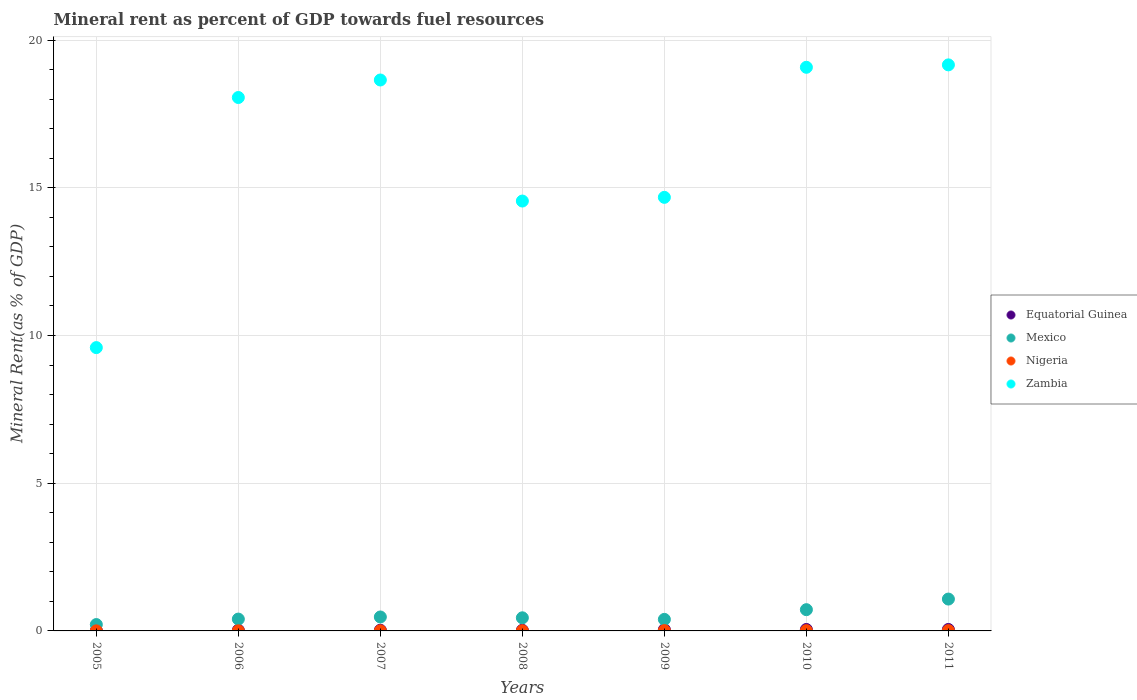How many different coloured dotlines are there?
Your answer should be very brief. 4. Is the number of dotlines equal to the number of legend labels?
Ensure brevity in your answer.  Yes. What is the mineral rent in Nigeria in 2007?
Keep it short and to the point. 0. Across all years, what is the maximum mineral rent in Nigeria?
Give a very brief answer. 0.01. Across all years, what is the minimum mineral rent in Nigeria?
Provide a short and direct response. 0. What is the total mineral rent in Nigeria in the graph?
Ensure brevity in your answer.  0.05. What is the difference between the mineral rent in Equatorial Guinea in 2006 and that in 2008?
Your answer should be very brief. 0. What is the difference between the mineral rent in Zambia in 2011 and the mineral rent in Equatorial Guinea in 2009?
Provide a succinct answer. 19.12. What is the average mineral rent in Equatorial Guinea per year?
Ensure brevity in your answer.  0.03. In the year 2008, what is the difference between the mineral rent in Nigeria and mineral rent in Mexico?
Keep it short and to the point. -0.44. What is the ratio of the mineral rent in Equatorial Guinea in 2006 to that in 2010?
Your answer should be very brief. 0.48. Is the mineral rent in Equatorial Guinea in 2005 less than that in 2007?
Your answer should be very brief. Yes. What is the difference between the highest and the second highest mineral rent in Zambia?
Your answer should be compact. 0.08. What is the difference between the highest and the lowest mineral rent in Equatorial Guinea?
Give a very brief answer. 0.04. Is the sum of the mineral rent in Equatorial Guinea in 2009 and 2011 greater than the maximum mineral rent in Mexico across all years?
Your answer should be very brief. No. Is it the case that in every year, the sum of the mineral rent in Mexico and mineral rent in Equatorial Guinea  is greater than the sum of mineral rent in Zambia and mineral rent in Nigeria?
Provide a short and direct response. No. Does the mineral rent in Nigeria monotonically increase over the years?
Make the answer very short. No. How many dotlines are there?
Make the answer very short. 4. How many years are there in the graph?
Give a very brief answer. 7. What is the difference between two consecutive major ticks on the Y-axis?
Offer a terse response. 5. Are the values on the major ticks of Y-axis written in scientific E-notation?
Your answer should be compact. No. Does the graph contain any zero values?
Your answer should be very brief. No. Does the graph contain grids?
Your response must be concise. Yes. How many legend labels are there?
Offer a terse response. 4. What is the title of the graph?
Your answer should be very brief. Mineral rent as percent of GDP towards fuel resources. Does "Hungary" appear as one of the legend labels in the graph?
Your answer should be very brief. No. What is the label or title of the Y-axis?
Offer a very short reply. Mineral Rent(as % of GDP). What is the Mineral Rent(as % of GDP) of Equatorial Guinea in 2005?
Keep it short and to the point. 0.01. What is the Mineral Rent(as % of GDP) of Mexico in 2005?
Provide a succinct answer. 0.22. What is the Mineral Rent(as % of GDP) of Nigeria in 2005?
Provide a short and direct response. 0. What is the Mineral Rent(as % of GDP) in Zambia in 2005?
Your answer should be compact. 9.59. What is the Mineral Rent(as % of GDP) of Equatorial Guinea in 2006?
Your response must be concise. 0.02. What is the Mineral Rent(as % of GDP) in Mexico in 2006?
Provide a short and direct response. 0.4. What is the Mineral Rent(as % of GDP) of Nigeria in 2006?
Keep it short and to the point. 0. What is the Mineral Rent(as % of GDP) in Zambia in 2006?
Give a very brief answer. 18.06. What is the Mineral Rent(as % of GDP) of Equatorial Guinea in 2007?
Your response must be concise. 0.02. What is the Mineral Rent(as % of GDP) of Mexico in 2007?
Offer a terse response. 0.47. What is the Mineral Rent(as % of GDP) of Nigeria in 2007?
Ensure brevity in your answer.  0. What is the Mineral Rent(as % of GDP) in Zambia in 2007?
Your answer should be very brief. 18.65. What is the Mineral Rent(as % of GDP) of Equatorial Guinea in 2008?
Keep it short and to the point. 0.02. What is the Mineral Rent(as % of GDP) of Mexico in 2008?
Keep it short and to the point. 0.44. What is the Mineral Rent(as % of GDP) in Nigeria in 2008?
Your answer should be very brief. 0.01. What is the Mineral Rent(as % of GDP) of Zambia in 2008?
Your answer should be very brief. 14.55. What is the Mineral Rent(as % of GDP) of Equatorial Guinea in 2009?
Make the answer very short. 0.04. What is the Mineral Rent(as % of GDP) in Mexico in 2009?
Your answer should be compact. 0.39. What is the Mineral Rent(as % of GDP) of Nigeria in 2009?
Provide a short and direct response. 0.01. What is the Mineral Rent(as % of GDP) in Zambia in 2009?
Your answer should be very brief. 14.68. What is the Mineral Rent(as % of GDP) of Equatorial Guinea in 2010?
Give a very brief answer. 0.05. What is the Mineral Rent(as % of GDP) of Mexico in 2010?
Keep it short and to the point. 0.72. What is the Mineral Rent(as % of GDP) in Nigeria in 2010?
Ensure brevity in your answer.  0.01. What is the Mineral Rent(as % of GDP) of Zambia in 2010?
Make the answer very short. 19.08. What is the Mineral Rent(as % of GDP) in Equatorial Guinea in 2011?
Make the answer very short. 0.05. What is the Mineral Rent(as % of GDP) in Mexico in 2011?
Provide a short and direct response. 1.08. What is the Mineral Rent(as % of GDP) in Nigeria in 2011?
Provide a succinct answer. 0.01. What is the Mineral Rent(as % of GDP) of Zambia in 2011?
Keep it short and to the point. 19.16. Across all years, what is the maximum Mineral Rent(as % of GDP) in Equatorial Guinea?
Provide a short and direct response. 0.05. Across all years, what is the maximum Mineral Rent(as % of GDP) in Mexico?
Ensure brevity in your answer.  1.08. Across all years, what is the maximum Mineral Rent(as % of GDP) of Nigeria?
Offer a terse response. 0.01. Across all years, what is the maximum Mineral Rent(as % of GDP) of Zambia?
Give a very brief answer. 19.16. Across all years, what is the minimum Mineral Rent(as % of GDP) in Equatorial Guinea?
Keep it short and to the point. 0.01. Across all years, what is the minimum Mineral Rent(as % of GDP) of Mexico?
Your response must be concise. 0.22. Across all years, what is the minimum Mineral Rent(as % of GDP) of Nigeria?
Your answer should be very brief. 0. Across all years, what is the minimum Mineral Rent(as % of GDP) in Zambia?
Provide a short and direct response. 9.59. What is the total Mineral Rent(as % of GDP) of Equatorial Guinea in the graph?
Provide a short and direct response. 0.22. What is the total Mineral Rent(as % of GDP) in Mexico in the graph?
Offer a terse response. 3.72. What is the total Mineral Rent(as % of GDP) in Nigeria in the graph?
Provide a succinct answer. 0.05. What is the total Mineral Rent(as % of GDP) in Zambia in the graph?
Provide a short and direct response. 113.78. What is the difference between the Mineral Rent(as % of GDP) in Equatorial Guinea in 2005 and that in 2006?
Provide a succinct answer. -0.01. What is the difference between the Mineral Rent(as % of GDP) of Mexico in 2005 and that in 2006?
Your response must be concise. -0.19. What is the difference between the Mineral Rent(as % of GDP) in Nigeria in 2005 and that in 2006?
Offer a terse response. -0. What is the difference between the Mineral Rent(as % of GDP) of Zambia in 2005 and that in 2006?
Offer a terse response. -8.47. What is the difference between the Mineral Rent(as % of GDP) in Equatorial Guinea in 2005 and that in 2007?
Provide a succinct answer. -0.01. What is the difference between the Mineral Rent(as % of GDP) of Mexico in 2005 and that in 2007?
Keep it short and to the point. -0.26. What is the difference between the Mineral Rent(as % of GDP) in Nigeria in 2005 and that in 2007?
Give a very brief answer. -0. What is the difference between the Mineral Rent(as % of GDP) of Zambia in 2005 and that in 2007?
Provide a succinct answer. -9.06. What is the difference between the Mineral Rent(as % of GDP) of Equatorial Guinea in 2005 and that in 2008?
Provide a succinct answer. -0.01. What is the difference between the Mineral Rent(as % of GDP) in Mexico in 2005 and that in 2008?
Offer a very short reply. -0.23. What is the difference between the Mineral Rent(as % of GDP) of Nigeria in 2005 and that in 2008?
Your answer should be very brief. -0. What is the difference between the Mineral Rent(as % of GDP) in Zambia in 2005 and that in 2008?
Give a very brief answer. -4.96. What is the difference between the Mineral Rent(as % of GDP) in Equatorial Guinea in 2005 and that in 2009?
Your response must be concise. -0.03. What is the difference between the Mineral Rent(as % of GDP) in Mexico in 2005 and that in 2009?
Your answer should be compact. -0.18. What is the difference between the Mineral Rent(as % of GDP) in Nigeria in 2005 and that in 2009?
Make the answer very short. -0.01. What is the difference between the Mineral Rent(as % of GDP) of Zambia in 2005 and that in 2009?
Give a very brief answer. -5.09. What is the difference between the Mineral Rent(as % of GDP) of Equatorial Guinea in 2005 and that in 2010?
Offer a very short reply. -0.04. What is the difference between the Mineral Rent(as % of GDP) in Mexico in 2005 and that in 2010?
Your answer should be very brief. -0.5. What is the difference between the Mineral Rent(as % of GDP) in Nigeria in 2005 and that in 2010?
Keep it short and to the point. -0.01. What is the difference between the Mineral Rent(as % of GDP) of Zambia in 2005 and that in 2010?
Your answer should be very brief. -9.49. What is the difference between the Mineral Rent(as % of GDP) in Equatorial Guinea in 2005 and that in 2011?
Provide a succinct answer. -0.04. What is the difference between the Mineral Rent(as % of GDP) in Mexico in 2005 and that in 2011?
Keep it short and to the point. -0.86. What is the difference between the Mineral Rent(as % of GDP) of Nigeria in 2005 and that in 2011?
Give a very brief answer. -0.01. What is the difference between the Mineral Rent(as % of GDP) of Zambia in 2005 and that in 2011?
Offer a terse response. -9.57. What is the difference between the Mineral Rent(as % of GDP) of Equatorial Guinea in 2006 and that in 2007?
Your answer should be very brief. 0. What is the difference between the Mineral Rent(as % of GDP) in Mexico in 2006 and that in 2007?
Provide a short and direct response. -0.07. What is the difference between the Mineral Rent(as % of GDP) of Nigeria in 2006 and that in 2007?
Make the answer very short. -0. What is the difference between the Mineral Rent(as % of GDP) in Zambia in 2006 and that in 2007?
Your response must be concise. -0.59. What is the difference between the Mineral Rent(as % of GDP) in Equatorial Guinea in 2006 and that in 2008?
Provide a succinct answer. 0. What is the difference between the Mineral Rent(as % of GDP) of Mexico in 2006 and that in 2008?
Your response must be concise. -0.04. What is the difference between the Mineral Rent(as % of GDP) in Nigeria in 2006 and that in 2008?
Your response must be concise. -0. What is the difference between the Mineral Rent(as % of GDP) in Zambia in 2006 and that in 2008?
Offer a very short reply. 3.51. What is the difference between the Mineral Rent(as % of GDP) in Equatorial Guinea in 2006 and that in 2009?
Offer a very short reply. -0.02. What is the difference between the Mineral Rent(as % of GDP) in Mexico in 2006 and that in 2009?
Your answer should be very brief. 0.01. What is the difference between the Mineral Rent(as % of GDP) in Nigeria in 2006 and that in 2009?
Keep it short and to the point. -0.01. What is the difference between the Mineral Rent(as % of GDP) in Zambia in 2006 and that in 2009?
Provide a short and direct response. 3.38. What is the difference between the Mineral Rent(as % of GDP) of Equatorial Guinea in 2006 and that in 2010?
Provide a succinct answer. -0.03. What is the difference between the Mineral Rent(as % of GDP) of Mexico in 2006 and that in 2010?
Give a very brief answer. -0.32. What is the difference between the Mineral Rent(as % of GDP) of Nigeria in 2006 and that in 2010?
Make the answer very short. -0.01. What is the difference between the Mineral Rent(as % of GDP) of Zambia in 2006 and that in 2010?
Give a very brief answer. -1.02. What is the difference between the Mineral Rent(as % of GDP) in Equatorial Guinea in 2006 and that in 2011?
Your answer should be very brief. -0.03. What is the difference between the Mineral Rent(as % of GDP) of Mexico in 2006 and that in 2011?
Your answer should be compact. -0.68. What is the difference between the Mineral Rent(as % of GDP) in Nigeria in 2006 and that in 2011?
Your response must be concise. -0.01. What is the difference between the Mineral Rent(as % of GDP) in Zambia in 2006 and that in 2011?
Offer a terse response. -1.1. What is the difference between the Mineral Rent(as % of GDP) in Equatorial Guinea in 2007 and that in 2008?
Your answer should be very brief. 0. What is the difference between the Mineral Rent(as % of GDP) of Mexico in 2007 and that in 2008?
Give a very brief answer. 0.03. What is the difference between the Mineral Rent(as % of GDP) in Nigeria in 2007 and that in 2008?
Your answer should be compact. -0. What is the difference between the Mineral Rent(as % of GDP) of Zambia in 2007 and that in 2008?
Give a very brief answer. 4.1. What is the difference between the Mineral Rent(as % of GDP) in Equatorial Guinea in 2007 and that in 2009?
Your answer should be very brief. -0.02. What is the difference between the Mineral Rent(as % of GDP) of Mexico in 2007 and that in 2009?
Give a very brief answer. 0.08. What is the difference between the Mineral Rent(as % of GDP) of Nigeria in 2007 and that in 2009?
Ensure brevity in your answer.  -0.01. What is the difference between the Mineral Rent(as % of GDP) of Zambia in 2007 and that in 2009?
Give a very brief answer. 3.97. What is the difference between the Mineral Rent(as % of GDP) of Equatorial Guinea in 2007 and that in 2010?
Keep it short and to the point. -0.03. What is the difference between the Mineral Rent(as % of GDP) of Mexico in 2007 and that in 2010?
Your response must be concise. -0.25. What is the difference between the Mineral Rent(as % of GDP) of Nigeria in 2007 and that in 2010?
Provide a short and direct response. -0. What is the difference between the Mineral Rent(as % of GDP) of Zambia in 2007 and that in 2010?
Your answer should be very brief. -0.43. What is the difference between the Mineral Rent(as % of GDP) in Equatorial Guinea in 2007 and that in 2011?
Keep it short and to the point. -0.03. What is the difference between the Mineral Rent(as % of GDP) in Mexico in 2007 and that in 2011?
Your response must be concise. -0.61. What is the difference between the Mineral Rent(as % of GDP) in Nigeria in 2007 and that in 2011?
Provide a succinct answer. -0.01. What is the difference between the Mineral Rent(as % of GDP) of Zambia in 2007 and that in 2011?
Keep it short and to the point. -0.51. What is the difference between the Mineral Rent(as % of GDP) in Equatorial Guinea in 2008 and that in 2009?
Keep it short and to the point. -0.02. What is the difference between the Mineral Rent(as % of GDP) in Mexico in 2008 and that in 2009?
Ensure brevity in your answer.  0.05. What is the difference between the Mineral Rent(as % of GDP) in Nigeria in 2008 and that in 2009?
Offer a very short reply. -0. What is the difference between the Mineral Rent(as % of GDP) in Zambia in 2008 and that in 2009?
Give a very brief answer. -0.13. What is the difference between the Mineral Rent(as % of GDP) in Equatorial Guinea in 2008 and that in 2010?
Provide a short and direct response. -0.03. What is the difference between the Mineral Rent(as % of GDP) of Mexico in 2008 and that in 2010?
Make the answer very short. -0.28. What is the difference between the Mineral Rent(as % of GDP) in Nigeria in 2008 and that in 2010?
Provide a short and direct response. -0. What is the difference between the Mineral Rent(as % of GDP) of Zambia in 2008 and that in 2010?
Make the answer very short. -4.53. What is the difference between the Mineral Rent(as % of GDP) in Equatorial Guinea in 2008 and that in 2011?
Offer a very short reply. -0.03. What is the difference between the Mineral Rent(as % of GDP) in Mexico in 2008 and that in 2011?
Your answer should be very brief. -0.63. What is the difference between the Mineral Rent(as % of GDP) in Nigeria in 2008 and that in 2011?
Your answer should be very brief. -0. What is the difference between the Mineral Rent(as % of GDP) in Zambia in 2008 and that in 2011?
Offer a very short reply. -4.61. What is the difference between the Mineral Rent(as % of GDP) of Equatorial Guinea in 2009 and that in 2010?
Give a very brief answer. -0. What is the difference between the Mineral Rent(as % of GDP) in Mexico in 2009 and that in 2010?
Provide a short and direct response. -0.33. What is the difference between the Mineral Rent(as % of GDP) of Nigeria in 2009 and that in 2010?
Provide a succinct answer. 0. What is the difference between the Mineral Rent(as % of GDP) of Zambia in 2009 and that in 2010?
Provide a short and direct response. -4.4. What is the difference between the Mineral Rent(as % of GDP) of Equatorial Guinea in 2009 and that in 2011?
Provide a short and direct response. -0. What is the difference between the Mineral Rent(as % of GDP) in Mexico in 2009 and that in 2011?
Offer a very short reply. -0.69. What is the difference between the Mineral Rent(as % of GDP) in Zambia in 2009 and that in 2011?
Offer a very short reply. -4.48. What is the difference between the Mineral Rent(as % of GDP) in Mexico in 2010 and that in 2011?
Provide a succinct answer. -0.36. What is the difference between the Mineral Rent(as % of GDP) of Nigeria in 2010 and that in 2011?
Keep it short and to the point. -0. What is the difference between the Mineral Rent(as % of GDP) in Zambia in 2010 and that in 2011?
Your answer should be compact. -0.08. What is the difference between the Mineral Rent(as % of GDP) of Equatorial Guinea in 2005 and the Mineral Rent(as % of GDP) of Mexico in 2006?
Your answer should be compact. -0.39. What is the difference between the Mineral Rent(as % of GDP) in Equatorial Guinea in 2005 and the Mineral Rent(as % of GDP) in Nigeria in 2006?
Make the answer very short. 0.01. What is the difference between the Mineral Rent(as % of GDP) of Equatorial Guinea in 2005 and the Mineral Rent(as % of GDP) of Zambia in 2006?
Your answer should be compact. -18.05. What is the difference between the Mineral Rent(as % of GDP) of Mexico in 2005 and the Mineral Rent(as % of GDP) of Nigeria in 2006?
Offer a very short reply. 0.21. What is the difference between the Mineral Rent(as % of GDP) of Mexico in 2005 and the Mineral Rent(as % of GDP) of Zambia in 2006?
Offer a terse response. -17.84. What is the difference between the Mineral Rent(as % of GDP) in Nigeria in 2005 and the Mineral Rent(as % of GDP) in Zambia in 2006?
Your answer should be very brief. -18.06. What is the difference between the Mineral Rent(as % of GDP) in Equatorial Guinea in 2005 and the Mineral Rent(as % of GDP) in Mexico in 2007?
Offer a terse response. -0.46. What is the difference between the Mineral Rent(as % of GDP) in Equatorial Guinea in 2005 and the Mineral Rent(as % of GDP) in Nigeria in 2007?
Provide a succinct answer. 0.01. What is the difference between the Mineral Rent(as % of GDP) of Equatorial Guinea in 2005 and the Mineral Rent(as % of GDP) of Zambia in 2007?
Provide a succinct answer. -18.64. What is the difference between the Mineral Rent(as % of GDP) in Mexico in 2005 and the Mineral Rent(as % of GDP) in Nigeria in 2007?
Provide a succinct answer. 0.21. What is the difference between the Mineral Rent(as % of GDP) of Mexico in 2005 and the Mineral Rent(as % of GDP) of Zambia in 2007?
Offer a very short reply. -18.44. What is the difference between the Mineral Rent(as % of GDP) of Nigeria in 2005 and the Mineral Rent(as % of GDP) of Zambia in 2007?
Offer a very short reply. -18.65. What is the difference between the Mineral Rent(as % of GDP) of Equatorial Guinea in 2005 and the Mineral Rent(as % of GDP) of Mexico in 2008?
Offer a terse response. -0.43. What is the difference between the Mineral Rent(as % of GDP) in Equatorial Guinea in 2005 and the Mineral Rent(as % of GDP) in Nigeria in 2008?
Your answer should be very brief. 0.01. What is the difference between the Mineral Rent(as % of GDP) in Equatorial Guinea in 2005 and the Mineral Rent(as % of GDP) in Zambia in 2008?
Ensure brevity in your answer.  -14.54. What is the difference between the Mineral Rent(as % of GDP) of Mexico in 2005 and the Mineral Rent(as % of GDP) of Nigeria in 2008?
Ensure brevity in your answer.  0.21. What is the difference between the Mineral Rent(as % of GDP) in Mexico in 2005 and the Mineral Rent(as % of GDP) in Zambia in 2008?
Ensure brevity in your answer.  -14.34. What is the difference between the Mineral Rent(as % of GDP) in Nigeria in 2005 and the Mineral Rent(as % of GDP) in Zambia in 2008?
Ensure brevity in your answer.  -14.55. What is the difference between the Mineral Rent(as % of GDP) of Equatorial Guinea in 2005 and the Mineral Rent(as % of GDP) of Mexico in 2009?
Your response must be concise. -0.38. What is the difference between the Mineral Rent(as % of GDP) of Equatorial Guinea in 2005 and the Mineral Rent(as % of GDP) of Zambia in 2009?
Your response must be concise. -14.67. What is the difference between the Mineral Rent(as % of GDP) in Mexico in 2005 and the Mineral Rent(as % of GDP) in Nigeria in 2009?
Your answer should be compact. 0.2. What is the difference between the Mineral Rent(as % of GDP) in Mexico in 2005 and the Mineral Rent(as % of GDP) in Zambia in 2009?
Your response must be concise. -14.46. What is the difference between the Mineral Rent(as % of GDP) in Nigeria in 2005 and the Mineral Rent(as % of GDP) in Zambia in 2009?
Offer a very short reply. -14.68. What is the difference between the Mineral Rent(as % of GDP) of Equatorial Guinea in 2005 and the Mineral Rent(as % of GDP) of Mexico in 2010?
Your answer should be very brief. -0.71. What is the difference between the Mineral Rent(as % of GDP) in Equatorial Guinea in 2005 and the Mineral Rent(as % of GDP) in Nigeria in 2010?
Your answer should be compact. 0. What is the difference between the Mineral Rent(as % of GDP) of Equatorial Guinea in 2005 and the Mineral Rent(as % of GDP) of Zambia in 2010?
Offer a very short reply. -19.07. What is the difference between the Mineral Rent(as % of GDP) of Mexico in 2005 and the Mineral Rent(as % of GDP) of Nigeria in 2010?
Provide a succinct answer. 0.21. What is the difference between the Mineral Rent(as % of GDP) in Mexico in 2005 and the Mineral Rent(as % of GDP) in Zambia in 2010?
Keep it short and to the point. -18.87. What is the difference between the Mineral Rent(as % of GDP) of Nigeria in 2005 and the Mineral Rent(as % of GDP) of Zambia in 2010?
Your answer should be compact. -19.08. What is the difference between the Mineral Rent(as % of GDP) in Equatorial Guinea in 2005 and the Mineral Rent(as % of GDP) in Mexico in 2011?
Ensure brevity in your answer.  -1.07. What is the difference between the Mineral Rent(as % of GDP) in Equatorial Guinea in 2005 and the Mineral Rent(as % of GDP) in Nigeria in 2011?
Provide a short and direct response. 0. What is the difference between the Mineral Rent(as % of GDP) of Equatorial Guinea in 2005 and the Mineral Rent(as % of GDP) of Zambia in 2011?
Your answer should be compact. -19.15. What is the difference between the Mineral Rent(as % of GDP) of Mexico in 2005 and the Mineral Rent(as % of GDP) of Nigeria in 2011?
Keep it short and to the point. 0.21. What is the difference between the Mineral Rent(as % of GDP) of Mexico in 2005 and the Mineral Rent(as % of GDP) of Zambia in 2011?
Ensure brevity in your answer.  -18.95. What is the difference between the Mineral Rent(as % of GDP) of Nigeria in 2005 and the Mineral Rent(as % of GDP) of Zambia in 2011?
Give a very brief answer. -19.16. What is the difference between the Mineral Rent(as % of GDP) of Equatorial Guinea in 2006 and the Mineral Rent(as % of GDP) of Mexico in 2007?
Keep it short and to the point. -0.45. What is the difference between the Mineral Rent(as % of GDP) in Equatorial Guinea in 2006 and the Mineral Rent(as % of GDP) in Nigeria in 2007?
Your answer should be compact. 0.02. What is the difference between the Mineral Rent(as % of GDP) of Equatorial Guinea in 2006 and the Mineral Rent(as % of GDP) of Zambia in 2007?
Ensure brevity in your answer.  -18.63. What is the difference between the Mineral Rent(as % of GDP) in Mexico in 2006 and the Mineral Rent(as % of GDP) in Nigeria in 2007?
Keep it short and to the point. 0.4. What is the difference between the Mineral Rent(as % of GDP) of Mexico in 2006 and the Mineral Rent(as % of GDP) of Zambia in 2007?
Ensure brevity in your answer.  -18.25. What is the difference between the Mineral Rent(as % of GDP) in Nigeria in 2006 and the Mineral Rent(as % of GDP) in Zambia in 2007?
Provide a short and direct response. -18.65. What is the difference between the Mineral Rent(as % of GDP) of Equatorial Guinea in 2006 and the Mineral Rent(as % of GDP) of Mexico in 2008?
Your answer should be compact. -0.42. What is the difference between the Mineral Rent(as % of GDP) in Equatorial Guinea in 2006 and the Mineral Rent(as % of GDP) in Nigeria in 2008?
Ensure brevity in your answer.  0.02. What is the difference between the Mineral Rent(as % of GDP) in Equatorial Guinea in 2006 and the Mineral Rent(as % of GDP) in Zambia in 2008?
Your answer should be compact. -14.53. What is the difference between the Mineral Rent(as % of GDP) in Mexico in 2006 and the Mineral Rent(as % of GDP) in Nigeria in 2008?
Offer a very short reply. 0.39. What is the difference between the Mineral Rent(as % of GDP) in Mexico in 2006 and the Mineral Rent(as % of GDP) in Zambia in 2008?
Ensure brevity in your answer.  -14.15. What is the difference between the Mineral Rent(as % of GDP) of Nigeria in 2006 and the Mineral Rent(as % of GDP) of Zambia in 2008?
Ensure brevity in your answer.  -14.55. What is the difference between the Mineral Rent(as % of GDP) in Equatorial Guinea in 2006 and the Mineral Rent(as % of GDP) in Mexico in 2009?
Make the answer very short. -0.37. What is the difference between the Mineral Rent(as % of GDP) of Equatorial Guinea in 2006 and the Mineral Rent(as % of GDP) of Nigeria in 2009?
Make the answer very short. 0.01. What is the difference between the Mineral Rent(as % of GDP) in Equatorial Guinea in 2006 and the Mineral Rent(as % of GDP) in Zambia in 2009?
Your answer should be compact. -14.65. What is the difference between the Mineral Rent(as % of GDP) in Mexico in 2006 and the Mineral Rent(as % of GDP) in Nigeria in 2009?
Give a very brief answer. 0.39. What is the difference between the Mineral Rent(as % of GDP) of Mexico in 2006 and the Mineral Rent(as % of GDP) of Zambia in 2009?
Your response must be concise. -14.28. What is the difference between the Mineral Rent(as % of GDP) in Nigeria in 2006 and the Mineral Rent(as % of GDP) in Zambia in 2009?
Provide a succinct answer. -14.68. What is the difference between the Mineral Rent(as % of GDP) of Equatorial Guinea in 2006 and the Mineral Rent(as % of GDP) of Mexico in 2010?
Keep it short and to the point. -0.7. What is the difference between the Mineral Rent(as % of GDP) of Equatorial Guinea in 2006 and the Mineral Rent(as % of GDP) of Nigeria in 2010?
Your answer should be very brief. 0.01. What is the difference between the Mineral Rent(as % of GDP) of Equatorial Guinea in 2006 and the Mineral Rent(as % of GDP) of Zambia in 2010?
Give a very brief answer. -19.06. What is the difference between the Mineral Rent(as % of GDP) in Mexico in 2006 and the Mineral Rent(as % of GDP) in Nigeria in 2010?
Provide a succinct answer. 0.39. What is the difference between the Mineral Rent(as % of GDP) in Mexico in 2006 and the Mineral Rent(as % of GDP) in Zambia in 2010?
Provide a short and direct response. -18.68. What is the difference between the Mineral Rent(as % of GDP) in Nigeria in 2006 and the Mineral Rent(as % of GDP) in Zambia in 2010?
Offer a terse response. -19.08. What is the difference between the Mineral Rent(as % of GDP) in Equatorial Guinea in 2006 and the Mineral Rent(as % of GDP) in Mexico in 2011?
Make the answer very short. -1.06. What is the difference between the Mineral Rent(as % of GDP) of Equatorial Guinea in 2006 and the Mineral Rent(as % of GDP) of Nigeria in 2011?
Make the answer very short. 0.01. What is the difference between the Mineral Rent(as % of GDP) of Equatorial Guinea in 2006 and the Mineral Rent(as % of GDP) of Zambia in 2011?
Your response must be concise. -19.14. What is the difference between the Mineral Rent(as % of GDP) in Mexico in 2006 and the Mineral Rent(as % of GDP) in Nigeria in 2011?
Provide a short and direct response. 0.39. What is the difference between the Mineral Rent(as % of GDP) in Mexico in 2006 and the Mineral Rent(as % of GDP) in Zambia in 2011?
Keep it short and to the point. -18.76. What is the difference between the Mineral Rent(as % of GDP) in Nigeria in 2006 and the Mineral Rent(as % of GDP) in Zambia in 2011?
Offer a very short reply. -19.16. What is the difference between the Mineral Rent(as % of GDP) in Equatorial Guinea in 2007 and the Mineral Rent(as % of GDP) in Mexico in 2008?
Offer a very short reply. -0.42. What is the difference between the Mineral Rent(as % of GDP) in Equatorial Guinea in 2007 and the Mineral Rent(as % of GDP) in Nigeria in 2008?
Ensure brevity in your answer.  0.02. What is the difference between the Mineral Rent(as % of GDP) of Equatorial Guinea in 2007 and the Mineral Rent(as % of GDP) of Zambia in 2008?
Offer a terse response. -14.53. What is the difference between the Mineral Rent(as % of GDP) of Mexico in 2007 and the Mineral Rent(as % of GDP) of Nigeria in 2008?
Make the answer very short. 0.47. What is the difference between the Mineral Rent(as % of GDP) of Mexico in 2007 and the Mineral Rent(as % of GDP) of Zambia in 2008?
Provide a short and direct response. -14.08. What is the difference between the Mineral Rent(as % of GDP) in Nigeria in 2007 and the Mineral Rent(as % of GDP) in Zambia in 2008?
Give a very brief answer. -14.55. What is the difference between the Mineral Rent(as % of GDP) of Equatorial Guinea in 2007 and the Mineral Rent(as % of GDP) of Mexico in 2009?
Make the answer very short. -0.37. What is the difference between the Mineral Rent(as % of GDP) of Equatorial Guinea in 2007 and the Mineral Rent(as % of GDP) of Nigeria in 2009?
Ensure brevity in your answer.  0.01. What is the difference between the Mineral Rent(as % of GDP) in Equatorial Guinea in 2007 and the Mineral Rent(as % of GDP) in Zambia in 2009?
Offer a terse response. -14.66. What is the difference between the Mineral Rent(as % of GDP) of Mexico in 2007 and the Mineral Rent(as % of GDP) of Nigeria in 2009?
Offer a very short reply. 0.46. What is the difference between the Mineral Rent(as % of GDP) of Mexico in 2007 and the Mineral Rent(as % of GDP) of Zambia in 2009?
Ensure brevity in your answer.  -14.21. What is the difference between the Mineral Rent(as % of GDP) of Nigeria in 2007 and the Mineral Rent(as % of GDP) of Zambia in 2009?
Ensure brevity in your answer.  -14.67. What is the difference between the Mineral Rent(as % of GDP) in Equatorial Guinea in 2007 and the Mineral Rent(as % of GDP) in Mexico in 2010?
Make the answer very short. -0.7. What is the difference between the Mineral Rent(as % of GDP) in Equatorial Guinea in 2007 and the Mineral Rent(as % of GDP) in Nigeria in 2010?
Your answer should be very brief. 0.01. What is the difference between the Mineral Rent(as % of GDP) in Equatorial Guinea in 2007 and the Mineral Rent(as % of GDP) in Zambia in 2010?
Your answer should be very brief. -19.06. What is the difference between the Mineral Rent(as % of GDP) of Mexico in 2007 and the Mineral Rent(as % of GDP) of Nigeria in 2010?
Offer a very short reply. 0.46. What is the difference between the Mineral Rent(as % of GDP) of Mexico in 2007 and the Mineral Rent(as % of GDP) of Zambia in 2010?
Your answer should be very brief. -18.61. What is the difference between the Mineral Rent(as % of GDP) in Nigeria in 2007 and the Mineral Rent(as % of GDP) in Zambia in 2010?
Provide a short and direct response. -19.08. What is the difference between the Mineral Rent(as % of GDP) in Equatorial Guinea in 2007 and the Mineral Rent(as % of GDP) in Mexico in 2011?
Your answer should be compact. -1.06. What is the difference between the Mineral Rent(as % of GDP) of Equatorial Guinea in 2007 and the Mineral Rent(as % of GDP) of Nigeria in 2011?
Provide a short and direct response. 0.01. What is the difference between the Mineral Rent(as % of GDP) in Equatorial Guinea in 2007 and the Mineral Rent(as % of GDP) in Zambia in 2011?
Your answer should be compact. -19.14. What is the difference between the Mineral Rent(as % of GDP) of Mexico in 2007 and the Mineral Rent(as % of GDP) of Nigeria in 2011?
Your answer should be compact. 0.46. What is the difference between the Mineral Rent(as % of GDP) in Mexico in 2007 and the Mineral Rent(as % of GDP) in Zambia in 2011?
Provide a short and direct response. -18.69. What is the difference between the Mineral Rent(as % of GDP) in Nigeria in 2007 and the Mineral Rent(as % of GDP) in Zambia in 2011?
Your answer should be compact. -19.16. What is the difference between the Mineral Rent(as % of GDP) of Equatorial Guinea in 2008 and the Mineral Rent(as % of GDP) of Mexico in 2009?
Ensure brevity in your answer.  -0.37. What is the difference between the Mineral Rent(as % of GDP) in Equatorial Guinea in 2008 and the Mineral Rent(as % of GDP) in Nigeria in 2009?
Keep it short and to the point. 0.01. What is the difference between the Mineral Rent(as % of GDP) in Equatorial Guinea in 2008 and the Mineral Rent(as % of GDP) in Zambia in 2009?
Offer a terse response. -14.66. What is the difference between the Mineral Rent(as % of GDP) in Mexico in 2008 and the Mineral Rent(as % of GDP) in Nigeria in 2009?
Ensure brevity in your answer.  0.43. What is the difference between the Mineral Rent(as % of GDP) of Mexico in 2008 and the Mineral Rent(as % of GDP) of Zambia in 2009?
Your answer should be very brief. -14.23. What is the difference between the Mineral Rent(as % of GDP) of Nigeria in 2008 and the Mineral Rent(as % of GDP) of Zambia in 2009?
Offer a terse response. -14.67. What is the difference between the Mineral Rent(as % of GDP) in Equatorial Guinea in 2008 and the Mineral Rent(as % of GDP) in Mexico in 2010?
Provide a short and direct response. -0.7. What is the difference between the Mineral Rent(as % of GDP) in Equatorial Guinea in 2008 and the Mineral Rent(as % of GDP) in Nigeria in 2010?
Keep it short and to the point. 0.01. What is the difference between the Mineral Rent(as % of GDP) in Equatorial Guinea in 2008 and the Mineral Rent(as % of GDP) in Zambia in 2010?
Your answer should be very brief. -19.06. What is the difference between the Mineral Rent(as % of GDP) of Mexico in 2008 and the Mineral Rent(as % of GDP) of Nigeria in 2010?
Your answer should be very brief. 0.43. What is the difference between the Mineral Rent(as % of GDP) in Mexico in 2008 and the Mineral Rent(as % of GDP) in Zambia in 2010?
Provide a short and direct response. -18.64. What is the difference between the Mineral Rent(as % of GDP) of Nigeria in 2008 and the Mineral Rent(as % of GDP) of Zambia in 2010?
Keep it short and to the point. -19.08. What is the difference between the Mineral Rent(as % of GDP) in Equatorial Guinea in 2008 and the Mineral Rent(as % of GDP) in Mexico in 2011?
Make the answer very short. -1.06. What is the difference between the Mineral Rent(as % of GDP) in Equatorial Guinea in 2008 and the Mineral Rent(as % of GDP) in Nigeria in 2011?
Provide a succinct answer. 0.01. What is the difference between the Mineral Rent(as % of GDP) of Equatorial Guinea in 2008 and the Mineral Rent(as % of GDP) of Zambia in 2011?
Offer a terse response. -19.14. What is the difference between the Mineral Rent(as % of GDP) in Mexico in 2008 and the Mineral Rent(as % of GDP) in Nigeria in 2011?
Make the answer very short. 0.43. What is the difference between the Mineral Rent(as % of GDP) of Mexico in 2008 and the Mineral Rent(as % of GDP) of Zambia in 2011?
Ensure brevity in your answer.  -18.72. What is the difference between the Mineral Rent(as % of GDP) in Nigeria in 2008 and the Mineral Rent(as % of GDP) in Zambia in 2011?
Ensure brevity in your answer.  -19.16. What is the difference between the Mineral Rent(as % of GDP) of Equatorial Guinea in 2009 and the Mineral Rent(as % of GDP) of Mexico in 2010?
Provide a succinct answer. -0.68. What is the difference between the Mineral Rent(as % of GDP) in Equatorial Guinea in 2009 and the Mineral Rent(as % of GDP) in Nigeria in 2010?
Your answer should be compact. 0.03. What is the difference between the Mineral Rent(as % of GDP) in Equatorial Guinea in 2009 and the Mineral Rent(as % of GDP) in Zambia in 2010?
Make the answer very short. -19.04. What is the difference between the Mineral Rent(as % of GDP) in Mexico in 2009 and the Mineral Rent(as % of GDP) in Nigeria in 2010?
Give a very brief answer. 0.38. What is the difference between the Mineral Rent(as % of GDP) in Mexico in 2009 and the Mineral Rent(as % of GDP) in Zambia in 2010?
Make the answer very short. -18.69. What is the difference between the Mineral Rent(as % of GDP) in Nigeria in 2009 and the Mineral Rent(as % of GDP) in Zambia in 2010?
Your answer should be compact. -19.07. What is the difference between the Mineral Rent(as % of GDP) of Equatorial Guinea in 2009 and the Mineral Rent(as % of GDP) of Mexico in 2011?
Give a very brief answer. -1.03. What is the difference between the Mineral Rent(as % of GDP) of Equatorial Guinea in 2009 and the Mineral Rent(as % of GDP) of Nigeria in 2011?
Provide a short and direct response. 0.03. What is the difference between the Mineral Rent(as % of GDP) of Equatorial Guinea in 2009 and the Mineral Rent(as % of GDP) of Zambia in 2011?
Your answer should be very brief. -19.12. What is the difference between the Mineral Rent(as % of GDP) in Mexico in 2009 and the Mineral Rent(as % of GDP) in Nigeria in 2011?
Your answer should be compact. 0.38. What is the difference between the Mineral Rent(as % of GDP) in Mexico in 2009 and the Mineral Rent(as % of GDP) in Zambia in 2011?
Offer a terse response. -18.77. What is the difference between the Mineral Rent(as % of GDP) in Nigeria in 2009 and the Mineral Rent(as % of GDP) in Zambia in 2011?
Your answer should be very brief. -19.15. What is the difference between the Mineral Rent(as % of GDP) of Equatorial Guinea in 2010 and the Mineral Rent(as % of GDP) of Mexico in 2011?
Your answer should be very brief. -1.03. What is the difference between the Mineral Rent(as % of GDP) of Equatorial Guinea in 2010 and the Mineral Rent(as % of GDP) of Nigeria in 2011?
Offer a terse response. 0.04. What is the difference between the Mineral Rent(as % of GDP) in Equatorial Guinea in 2010 and the Mineral Rent(as % of GDP) in Zambia in 2011?
Offer a very short reply. -19.11. What is the difference between the Mineral Rent(as % of GDP) of Mexico in 2010 and the Mineral Rent(as % of GDP) of Nigeria in 2011?
Offer a very short reply. 0.71. What is the difference between the Mineral Rent(as % of GDP) of Mexico in 2010 and the Mineral Rent(as % of GDP) of Zambia in 2011?
Offer a terse response. -18.44. What is the difference between the Mineral Rent(as % of GDP) of Nigeria in 2010 and the Mineral Rent(as % of GDP) of Zambia in 2011?
Your answer should be very brief. -19.15. What is the average Mineral Rent(as % of GDP) of Equatorial Guinea per year?
Offer a very short reply. 0.03. What is the average Mineral Rent(as % of GDP) in Mexico per year?
Offer a terse response. 0.53. What is the average Mineral Rent(as % of GDP) in Nigeria per year?
Offer a terse response. 0.01. What is the average Mineral Rent(as % of GDP) of Zambia per year?
Your response must be concise. 16.25. In the year 2005, what is the difference between the Mineral Rent(as % of GDP) of Equatorial Guinea and Mineral Rent(as % of GDP) of Mexico?
Your response must be concise. -0.2. In the year 2005, what is the difference between the Mineral Rent(as % of GDP) of Equatorial Guinea and Mineral Rent(as % of GDP) of Nigeria?
Your answer should be very brief. 0.01. In the year 2005, what is the difference between the Mineral Rent(as % of GDP) of Equatorial Guinea and Mineral Rent(as % of GDP) of Zambia?
Ensure brevity in your answer.  -9.58. In the year 2005, what is the difference between the Mineral Rent(as % of GDP) in Mexico and Mineral Rent(as % of GDP) in Nigeria?
Offer a terse response. 0.21. In the year 2005, what is the difference between the Mineral Rent(as % of GDP) of Mexico and Mineral Rent(as % of GDP) of Zambia?
Offer a very short reply. -9.38. In the year 2005, what is the difference between the Mineral Rent(as % of GDP) in Nigeria and Mineral Rent(as % of GDP) in Zambia?
Offer a terse response. -9.59. In the year 2006, what is the difference between the Mineral Rent(as % of GDP) of Equatorial Guinea and Mineral Rent(as % of GDP) of Mexico?
Ensure brevity in your answer.  -0.38. In the year 2006, what is the difference between the Mineral Rent(as % of GDP) of Equatorial Guinea and Mineral Rent(as % of GDP) of Nigeria?
Provide a short and direct response. 0.02. In the year 2006, what is the difference between the Mineral Rent(as % of GDP) in Equatorial Guinea and Mineral Rent(as % of GDP) in Zambia?
Your answer should be very brief. -18.03. In the year 2006, what is the difference between the Mineral Rent(as % of GDP) in Mexico and Mineral Rent(as % of GDP) in Nigeria?
Your answer should be very brief. 0.4. In the year 2006, what is the difference between the Mineral Rent(as % of GDP) of Mexico and Mineral Rent(as % of GDP) of Zambia?
Provide a short and direct response. -17.66. In the year 2006, what is the difference between the Mineral Rent(as % of GDP) in Nigeria and Mineral Rent(as % of GDP) in Zambia?
Make the answer very short. -18.05. In the year 2007, what is the difference between the Mineral Rent(as % of GDP) in Equatorial Guinea and Mineral Rent(as % of GDP) in Mexico?
Your response must be concise. -0.45. In the year 2007, what is the difference between the Mineral Rent(as % of GDP) of Equatorial Guinea and Mineral Rent(as % of GDP) of Nigeria?
Make the answer very short. 0.02. In the year 2007, what is the difference between the Mineral Rent(as % of GDP) of Equatorial Guinea and Mineral Rent(as % of GDP) of Zambia?
Your answer should be compact. -18.63. In the year 2007, what is the difference between the Mineral Rent(as % of GDP) of Mexico and Mineral Rent(as % of GDP) of Nigeria?
Ensure brevity in your answer.  0.47. In the year 2007, what is the difference between the Mineral Rent(as % of GDP) in Mexico and Mineral Rent(as % of GDP) in Zambia?
Offer a terse response. -18.18. In the year 2007, what is the difference between the Mineral Rent(as % of GDP) of Nigeria and Mineral Rent(as % of GDP) of Zambia?
Offer a terse response. -18.65. In the year 2008, what is the difference between the Mineral Rent(as % of GDP) in Equatorial Guinea and Mineral Rent(as % of GDP) in Mexico?
Ensure brevity in your answer.  -0.42. In the year 2008, what is the difference between the Mineral Rent(as % of GDP) of Equatorial Guinea and Mineral Rent(as % of GDP) of Nigeria?
Provide a short and direct response. 0.02. In the year 2008, what is the difference between the Mineral Rent(as % of GDP) of Equatorial Guinea and Mineral Rent(as % of GDP) of Zambia?
Your response must be concise. -14.53. In the year 2008, what is the difference between the Mineral Rent(as % of GDP) in Mexico and Mineral Rent(as % of GDP) in Nigeria?
Offer a very short reply. 0.44. In the year 2008, what is the difference between the Mineral Rent(as % of GDP) of Mexico and Mineral Rent(as % of GDP) of Zambia?
Offer a very short reply. -14.11. In the year 2008, what is the difference between the Mineral Rent(as % of GDP) in Nigeria and Mineral Rent(as % of GDP) in Zambia?
Provide a succinct answer. -14.55. In the year 2009, what is the difference between the Mineral Rent(as % of GDP) of Equatorial Guinea and Mineral Rent(as % of GDP) of Mexico?
Your response must be concise. -0.35. In the year 2009, what is the difference between the Mineral Rent(as % of GDP) of Equatorial Guinea and Mineral Rent(as % of GDP) of Nigeria?
Your answer should be compact. 0.03. In the year 2009, what is the difference between the Mineral Rent(as % of GDP) in Equatorial Guinea and Mineral Rent(as % of GDP) in Zambia?
Give a very brief answer. -14.63. In the year 2009, what is the difference between the Mineral Rent(as % of GDP) of Mexico and Mineral Rent(as % of GDP) of Nigeria?
Make the answer very short. 0.38. In the year 2009, what is the difference between the Mineral Rent(as % of GDP) of Mexico and Mineral Rent(as % of GDP) of Zambia?
Make the answer very short. -14.29. In the year 2009, what is the difference between the Mineral Rent(as % of GDP) of Nigeria and Mineral Rent(as % of GDP) of Zambia?
Offer a terse response. -14.67. In the year 2010, what is the difference between the Mineral Rent(as % of GDP) in Equatorial Guinea and Mineral Rent(as % of GDP) in Mexico?
Offer a terse response. -0.67. In the year 2010, what is the difference between the Mineral Rent(as % of GDP) in Equatorial Guinea and Mineral Rent(as % of GDP) in Nigeria?
Your response must be concise. 0.04. In the year 2010, what is the difference between the Mineral Rent(as % of GDP) in Equatorial Guinea and Mineral Rent(as % of GDP) in Zambia?
Make the answer very short. -19.03. In the year 2010, what is the difference between the Mineral Rent(as % of GDP) of Mexico and Mineral Rent(as % of GDP) of Nigeria?
Provide a short and direct response. 0.71. In the year 2010, what is the difference between the Mineral Rent(as % of GDP) in Mexico and Mineral Rent(as % of GDP) in Zambia?
Your response must be concise. -18.36. In the year 2010, what is the difference between the Mineral Rent(as % of GDP) of Nigeria and Mineral Rent(as % of GDP) of Zambia?
Offer a terse response. -19.07. In the year 2011, what is the difference between the Mineral Rent(as % of GDP) in Equatorial Guinea and Mineral Rent(as % of GDP) in Mexico?
Offer a very short reply. -1.03. In the year 2011, what is the difference between the Mineral Rent(as % of GDP) in Equatorial Guinea and Mineral Rent(as % of GDP) in Nigeria?
Give a very brief answer. 0.04. In the year 2011, what is the difference between the Mineral Rent(as % of GDP) of Equatorial Guinea and Mineral Rent(as % of GDP) of Zambia?
Your answer should be very brief. -19.11. In the year 2011, what is the difference between the Mineral Rent(as % of GDP) in Mexico and Mineral Rent(as % of GDP) in Nigeria?
Offer a terse response. 1.07. In the year 2011, what is the difference between the Mineral Rent(as % of GDP) of Mexico and Mineral Rent(as % of GDP) of Zambia?
Keep it short and to the point. -18.08. In the year 2011, what is the difference between the Mineral Rent(as % of GDP) in Nigeria and Mineral Rent(as % of GDP) in Zambia?
Give a very brief answer. -19.15. What is the ratio of the Mineral Rent(as % of GDP) in Equatorial Guinea in 2005 to that in 2006?
Your answer should be compact. 0.47. What is the ratio of the Mineral Rent(as % of GDP) in Mexico in 2005 to that in 2006?
Offer a very short reply. 0.54. What is the ratio of the Mineral Rent(as % of GDP) of Nigeria in 2005 to that in 2006?
Your answer should be very brief. 0.79. What is the ratio of the Mineral Rent(as % of GDP) in Zambia in 2005 to that in 2006?
Keep it short and to the point. 0.53. What is the ratio of the Mineral Rent(as % of GDP) in Equatorial Guinea in 2005 to that in 2007?
Make the answer very short. 0.48. What is the ratio of the Mineral Rent(as % of GDP) in Mexico in 2005 to that in 2007?
Your answer should be compact. 0.46. What is the ratio of the Mineral Rent(as % of GDP) of Nigeria in 2005 to that in 2007?
Make the answer very short. 0.54. What is the ratio of the Mineral Rent(as % of GDP) in Zambia in 2005 to that in 2007?
Provide a succinct answer. 0.51. What is the ratio of the Mineral Rent(as % of GDP) of Equatorial Guinea in 2005 to that in 2008?
Provide a short and direct response. 0.51. What is the ratio of the Mineral Rent(as % of GDP) of Mexico in 2005 to that in 2008?
Ensure brevity in your answer.  0.48. What is the ratio of the Mineral Rent(as % of GDP) in Nigeria in 2005 to that in 2008?
Your answer should be compact. 0.43. What is the ratio of the Mineral Rent(as % of GDP) of Zambia in 2005 to that in 2008?
Keep it short and to the point. 0.66. What is the ratio of the Mineral Rent(as % of GDP) of Equatorial Guinea in 2005 to that in 2009?
Offer a very short reply. 0.25. What is the ratio of the Mineral Rent(as % of GDP) of Mexico in 2005 to that in 2009?
Your answer should be compact. 0.55. What is the ratio of the Mineral Rent(as % of GDP) of Nigeria in 2005 to that in 2009?
Your answer should be very brief. 0.24. What is the ratio of the Mineral Rent(as % of GDP) of Zambia in 2005 to that in 2009?
Provide a short and direct response. 0.65. What is the ratio of the Mineral Rent(as % of GDP) in Equatorial Guinea in 2005 to that in 2010?
Your response must be concise. 0.23. What is the ratio of the Mineral Rent(as % of GDP) in Mexico in 2005 to that in 2010?
Keep it short and to the point. 0.3. What is the ratio of the Mineral Rent(as % of GDP) in Nigeria in 2005 to that in 2010?
Provide a succinct answer. 0.28. What is the ratio of the Mineral Rent(as % of GDP) in Zambia in 2005 to that in 2010?
Your answer should be compact. 0.5. What is the ratio of the Mineral Rent(as % of GDP) in Equatorial Guinea in 2005 to that in 2011?
Your response must be concise. 0.23. What is the ratio of the Mineral Rent(as % of GDP) of Mexico in 2005 to that in 2011?
Give a very brief answer. 0.2. What is the ratio of the Mineral Rent(as % of GDP) in Nigeria in 2005 to that in 2011?
Offer a terse response. 0.26. What is the ratio of the Mineral Rent(as % of GDP) of Zambia in 2005 to that in 2011?
Your answer should be very brief. 0.5. What is the ratio of the Mineral Rent(as % of GDP) in Equatorial Guinea in 2006 to that in 2007?
Make the answer very short. 1.01. What is the ratio of the Mineral Rent(as % of GDP) in Mexico in 2006 to that in 2007?
Ensure brevity in your answer.  0.85. What is the ratio of the Mineral Rent(as % of GDP) in Nigeria in 2006 to that in 2007?
Your answer should be very brief. 0.68. What is the ratio of the Mineral Rent(as % of GDP) in Zambia in 2006 to that in 2007?
Keep it short and to the point. 0.97. What is the ratio of the Mineral Rent(as % of GDP) of Equatorial Guinea in 2006 to that in 2008?
Provide a succinct answer. 1.08. What is the ratio of the Mineral Rent(as % of GDP) in Mexico in 2006 to that in 2008?
Provide a short and direct response. 0.9. What is the ratio of the Mineral Rent(as % of GDP) in Nigeria in 2006 to that in 2008?
Offer a very short reply. 0.54. What is the ratio of the Mineral Rent(as % of GDP) in Zambia in 2006 to that in 2008?
Your response must be concise. 1.24. What is the ratio of the Mineral Rent(as % of GDP) of Equatorial Guinea in 2006 to that in 2009?
Your answer should be compact. 0.53. What is the ratio of the Mineral Rent(as % of GDP) of Mexico in 2006 to that in 2009?
Provide a succinct answer. 1.03. What is the ratio of the Mineral Rent(as % of GDP) of Nigeria in 2006 to that in 2009?
Your answer should be compact. 0.3. What is the ratio of the Mineral Rent(as % of GDP) in Zambia in 2006 to that in 2009?
Ensure brevity in your answer.  1.23. What is the ratio of the Mineral Rent(as % of GDP) in Equatorial Guinea in 2006 to that in 2010?
Your response must be concise. 0.48. What is the ratio of the Mineral Rent(as % of GDP) in Mexico in 2006 to that in 2010?
Offer a very short reply. 0.56. What is the ratio of the Mineral Rent(as % of GDP) of Nigeria in 2006 to that in 2010?
Your answer should be compact. 0.36. What is the ratio of the Mineral Rent(as % of GDP) in Zambia in 2006 to that in 2010?
Your response must be concise. 0.95. What is the ratio of the Mineral Rent(as % of GDP) of Equatorial Guinea in 2006 to that in 2011?
Your answer should be compact. 0.48. What is the ratio of the Mineral Rent(as % of GDP) of Mexico in 2006 to that in 2011?
Make the answer very short. 0.37. What is the ratio of the Mineral Rent(as % of GDP) of Nigeria in 2006 to that in 2011?
Offer a terse response. 0.33. What is the ratio of the Mineral Rent(as % of GDP) of Zambia in 2006 to that in 2011?
Your response must be concise. 0.94. What is the ratio of the Mineral Rent(as % of GDP) of Equatorial Guinea in 2007 to that in 2008?
Your answer should be very brief. 1.08. What is the ratio of the Mineral Rent(as % of GDP) in Mexico in 2007 to that in 2008?
Make the answer very short. 1.06. What is the ratio of the Mineral Rent(as % of GDP) in Nigeria in 2007 to that in 2008?
Offer a very short reply. 0.8. What is the ratio of the Mineral Rent(as % of GDP) in Zambia in 2007 to that in 2008?
Offer a terse response. 1.28. What is the ratio of the Mineral Rent(as % of GDP) of Equatorial Guinea in 2007 to that in 2009?
Your answer should be very brief. 0.53. What is the ratio of the Mineral Rent(as % of GDP) in Mexico in 2007 to that in 2009?
Keep it short and to the point. 1.21. What is the ratio of the Mineral Rent(as % of GDP) of Nigeria in 2007 to that in 2009?
Offer a terse response. 0.44. What is the ratio of the Mineral Rent(as % of GDP) in Zambia in 2007 to that in 2009?
Your answer should be compact. 1.27. What is the ratio of the Mineral Rent(as % of GDP) in Equatorial Guinea in 2007 to that in 2010?
Offer a very short reply. 0.47. What is the ratio of the Mineral Rent(as % of GDP) in Mexico in 2007 to that in 2010?
Offer a terse response. 0.66. What is the ratio of the Mineral Rent(as % of GDP) in Nigeria in 2007 to that in 2010?
Provide a succinct answer. 0.52. What is the ratio of the Mineral Rent(as % of GDP) of Zambia in 2007 to that in 2010?
Your answer should be compact. 0.98. What is the ratio of the Mineral Rent(as % of GDP) of Equatorial Guinea in 2007 to that in 2011?
Offer a terse response. 0.47. What is the ratio of the Mineral Rent(as % of GDP) of Mexico in 2007 to that in 2011?
Give a very brief answer. 0.44. What is the ratio of the Mineral Rent(as % of GDP) of Nigeria in 2007 to that in 2011?
Provide a short and direct response. 0.49. What is the ratio of the Mineral Rent(as % of GDP) of Zambia in 2007 to that in 2011?
Provide a succinct answer. 0.97. What is the ratio of the Mineral Rent(as % of GDP) in Equatorial Guinea in 2008 to that in 2009?
Offer a very short reply. 0.49. What is the ratio of the Mineral Rent(as % of GDP) in Mexico in 2008 to that in 2009?
Your answer should be compact. 1.14. What is the ratio of the Mineral Rent(as % of GDP) in Nigeria in 2008 to that in 2009?
Your response must be concise. 0.56. What is the ratio of the Mineral Rent(as % of GDP) of Equatorial Guinea in 2008 to that in 2010?
Offer a very short reply. 0.44. What is the ratio of the Mineral Rent(as % of GDP) in Mexico in 2008 to that in 2010?
Offer a terse response. 0.62. What is the ratio of the Mineral Rent(as % of GDP) of Nigeria in 2008 to that in 2010?
Your response must be concise. 0.65. What is the ratio of the Mineral Rent(as % of GDP) of Zambia in 2008 to that in 2010?
Your answer should be very brief. 0.76. What is the ratio of the Mineral Rent(as % of GDP) in Equatorial Guinea in 2008 to that in 2011?
Provide a short and direct response. 0.44. What is the ratio of the Mineral Rent(as % of GDP) in Mexico in 2008 to that in 2011?
Provide a short and direct response. 0.41. What is the ratio of the Mineral Rent(as % of GDP) of Nigeria in 2008 to that in 2011?
Offer a terse response. 0.61. What is the ratio of the Mineral Rent(as % of GDP) in Zambia in 2008 to that in 2011?
Ensure brevity in your answer.  0.76. What is the ratio of the Mineral Rent(as % of GDP) of Equatorial Guinea in 2009 to that in 2010?
Keep it short and to the point. 0.9. What is the ratio of the Mineral Rent(as % of GDP) of Mexico in 2009 to that in 2010?
Your response must be concise. 0.54. What is the ratio of the Mineral Rent(as % of GDP) in Nigeria in 2009 to that in 2010?
Your answer should be compact. 1.17. What is the ratio of the Mineral Rent(as % of GDP) of Zambia in 2009 to that in 2010?
Provide a short and direct response. 0.77. What is the ratio of the Mineral Rent(as % of GDP) of Equatorial Guinea in 2009 to that in 2011?
Give a very brief answer. 0.9. What is the ratio of the Mineral Rent(as % of GDP) of Mexico in 2009 to that in 2011?
Keep it short and to the point. 0.36. What is the ratio of the Mineral Rent(as % of GDP) in Nigeria in 2009 to that in 2011?
Give a very brief answer. 1.1. What is the ratio of the Mineral Rent(as % of GDP) in Zambia in 2009 to that in 2011?
Offer a terse response. 0.77. What is the ratio of the Mineral Rent(as % of GDP) of Mexico in 2010 to that in 2011?
Offer a terse response. 0.67. What is the ratio of the Mineral Rent(as % of GDP) in Nigeria in 2010 to that in 2011?
Offer a very short reply. 0.94. What is the ratio of the Mineral Rent(as % of GDP) in Zambia in 2010 to that in 2011?
Offer a terse response. 1. What is the difference between the highest and the second highest Mineral Rent(as % of GDP) of Equatorial Guinea?
Offer a terse response. 0. What is the difference between the highest and the second highest Mineral Rent(as % of GDP) of Mexico?
Keep it short and to the point. 0.36. What is the difference between the highest and the second highest Mineral Rent(as % of GDP) in Nigeria?
Your answer should be compact. 0. What is the difference between the highest and the second highest Mineral Rent(as % of GDP) in Zambia?
Offer a very short reply. 0.08. What is the difference between the highest and the lowest Mineral Rent(as % of GDP) of Equatorial Guinea?
Make the answer very short. 0.04. What is the difference between the highest and the lowest Mineral Rent(as % of GDP) of Mexico?
Provide a short and direct response. 0.86. What is the difference between the highest and the lowest Mineral Rent(as % of GDP) in Nigeria?
Offer a terse response. 0.01. What is the difference between the highest and the lowest Mineral Rent(as % of GDP) of Zambia?
Make the answer very short. 9.57. 